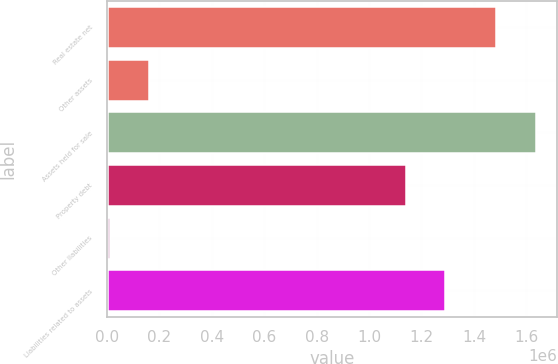Convert chart to OTSL. <chart><loc_0><loc_0><loc_500><loc_500><bar_chart><fcel>Real estate net<fcel>Other assets<fcel>Assets held for sale<fcel>Property debt<fcel>Other liabilities<fcel>Liabilities related to assets<nl><fcel>1.48544e+06<fcel>160222<fcel>1.63489e+06<fcel>1.14043e+06<fcel>10771<fcel>1.28988e+06<nl></chart> 